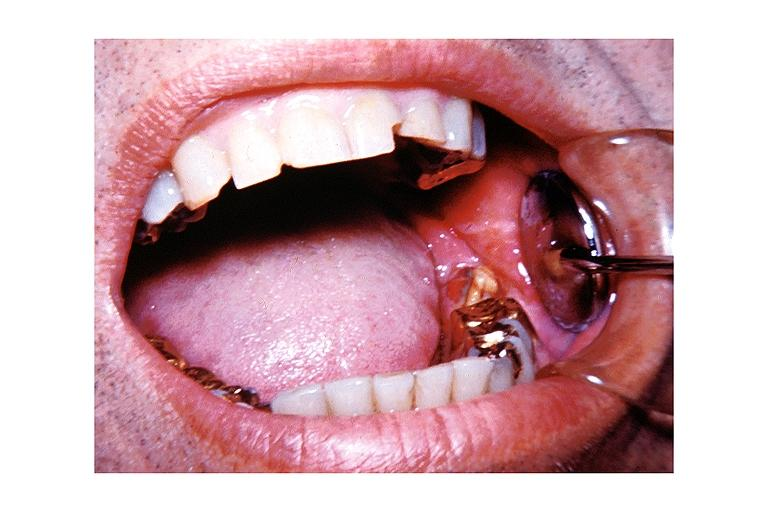what does this image show?
Answer the question using a single word or phrase. Chronic osteomyelitis 